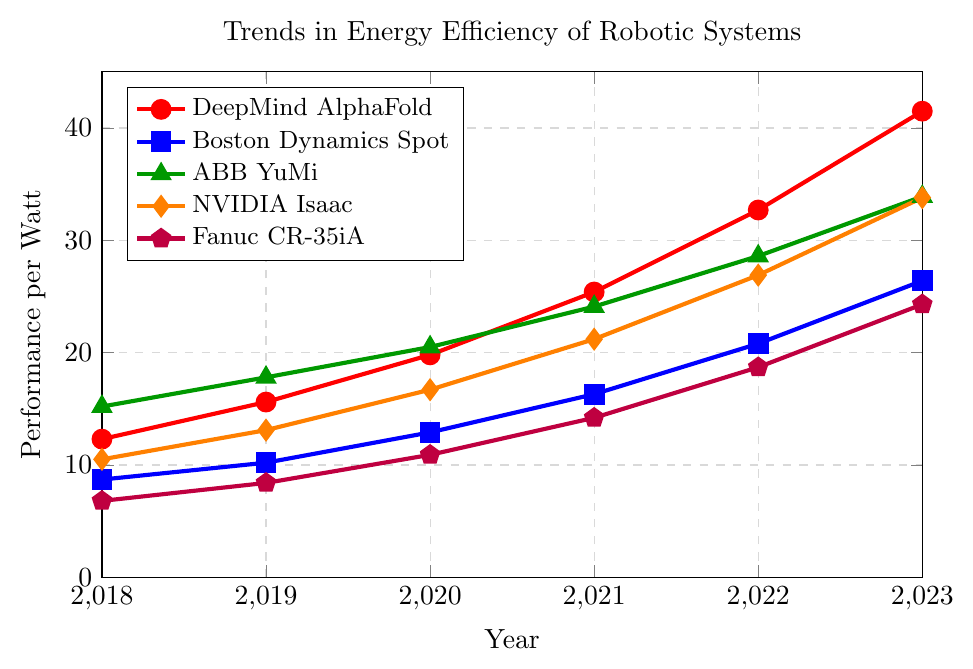What are the data points of DeepMind AlphaFold? Look for the red line with circle markers and note the y-values corresponding to each x-value (year) on the chart.
Answer: 12.3, 15.6, 19.8, 25.4, 32.7, 41.5 Which robotic system had the best energy efficiency in 2023? Check which line reaches the highest value on the y-axis for the year 2023. The red line (DeepMind AlphaFold) hits the highest y-value.
Answer: DeepMind AlphaFold Which system shows the most consistent increase in energy efficiency? Analyze the slopes of each line over the years and determine which has the steadiest increase. ABB YuMi (green line) has a consistent slope.
Answer: ABB YuMi Compare the performance per watt of the system with the lowest energy efficiency in 2018 and in 2023. Identify the lowest y-value for each year and compare them. In 2018, Fanuc CR-35iA is at 6.8; in 2023, it reaches 24.3.
Answer: 6.8 (2018), 24.3 (2023) 